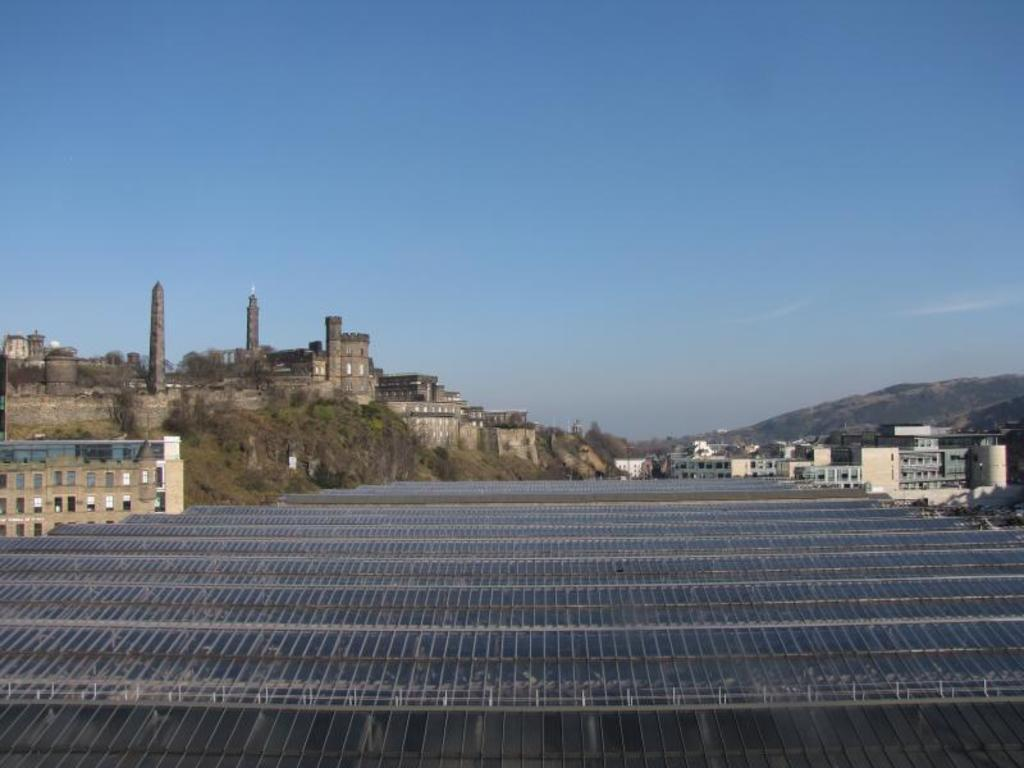What type of structure is visible in the image? The image contains a roof. What else can be seen in the image besides the roof? There are buildings and hills present in the image. What is the color of the sky in the image? The sky is visible in the background of the image, and it is described as blue. What degree of heat can be felt from the roof in the image? The image does not provide information about the temperature or heat, so it cannot be determined from the image. 